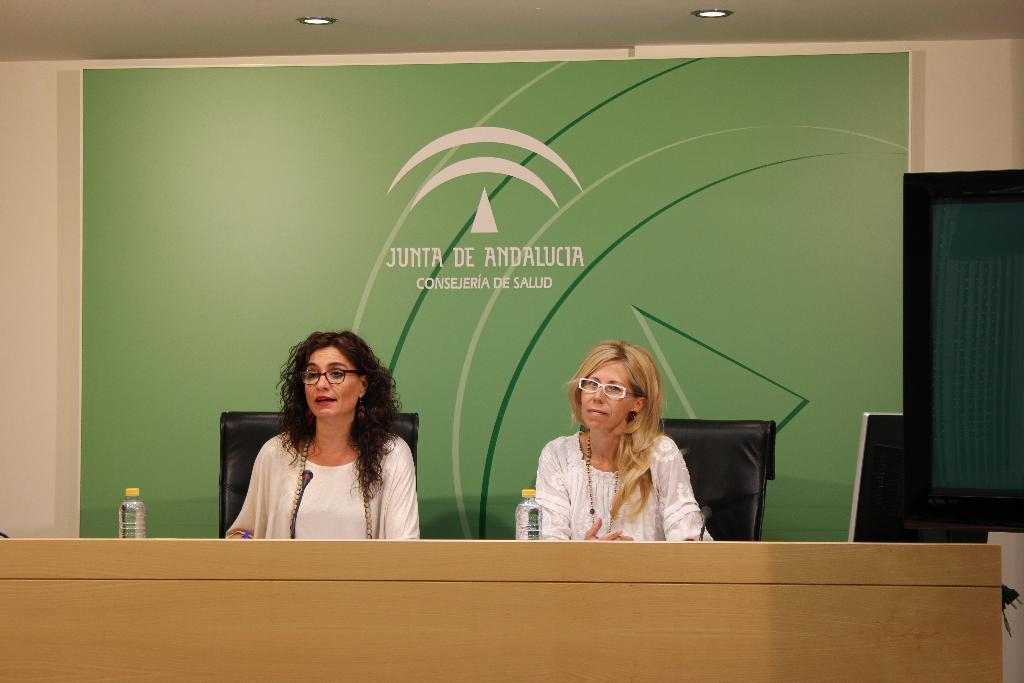Could you give a brief overview of what you see in this image? In this image we can see few people sitting on the chairs. There are few bottles placed on the table. There is an advertising board and some text printed on it. There a television at the right side of the image. There is an object at the right side of the image. We can see few lights at the top of the image. 